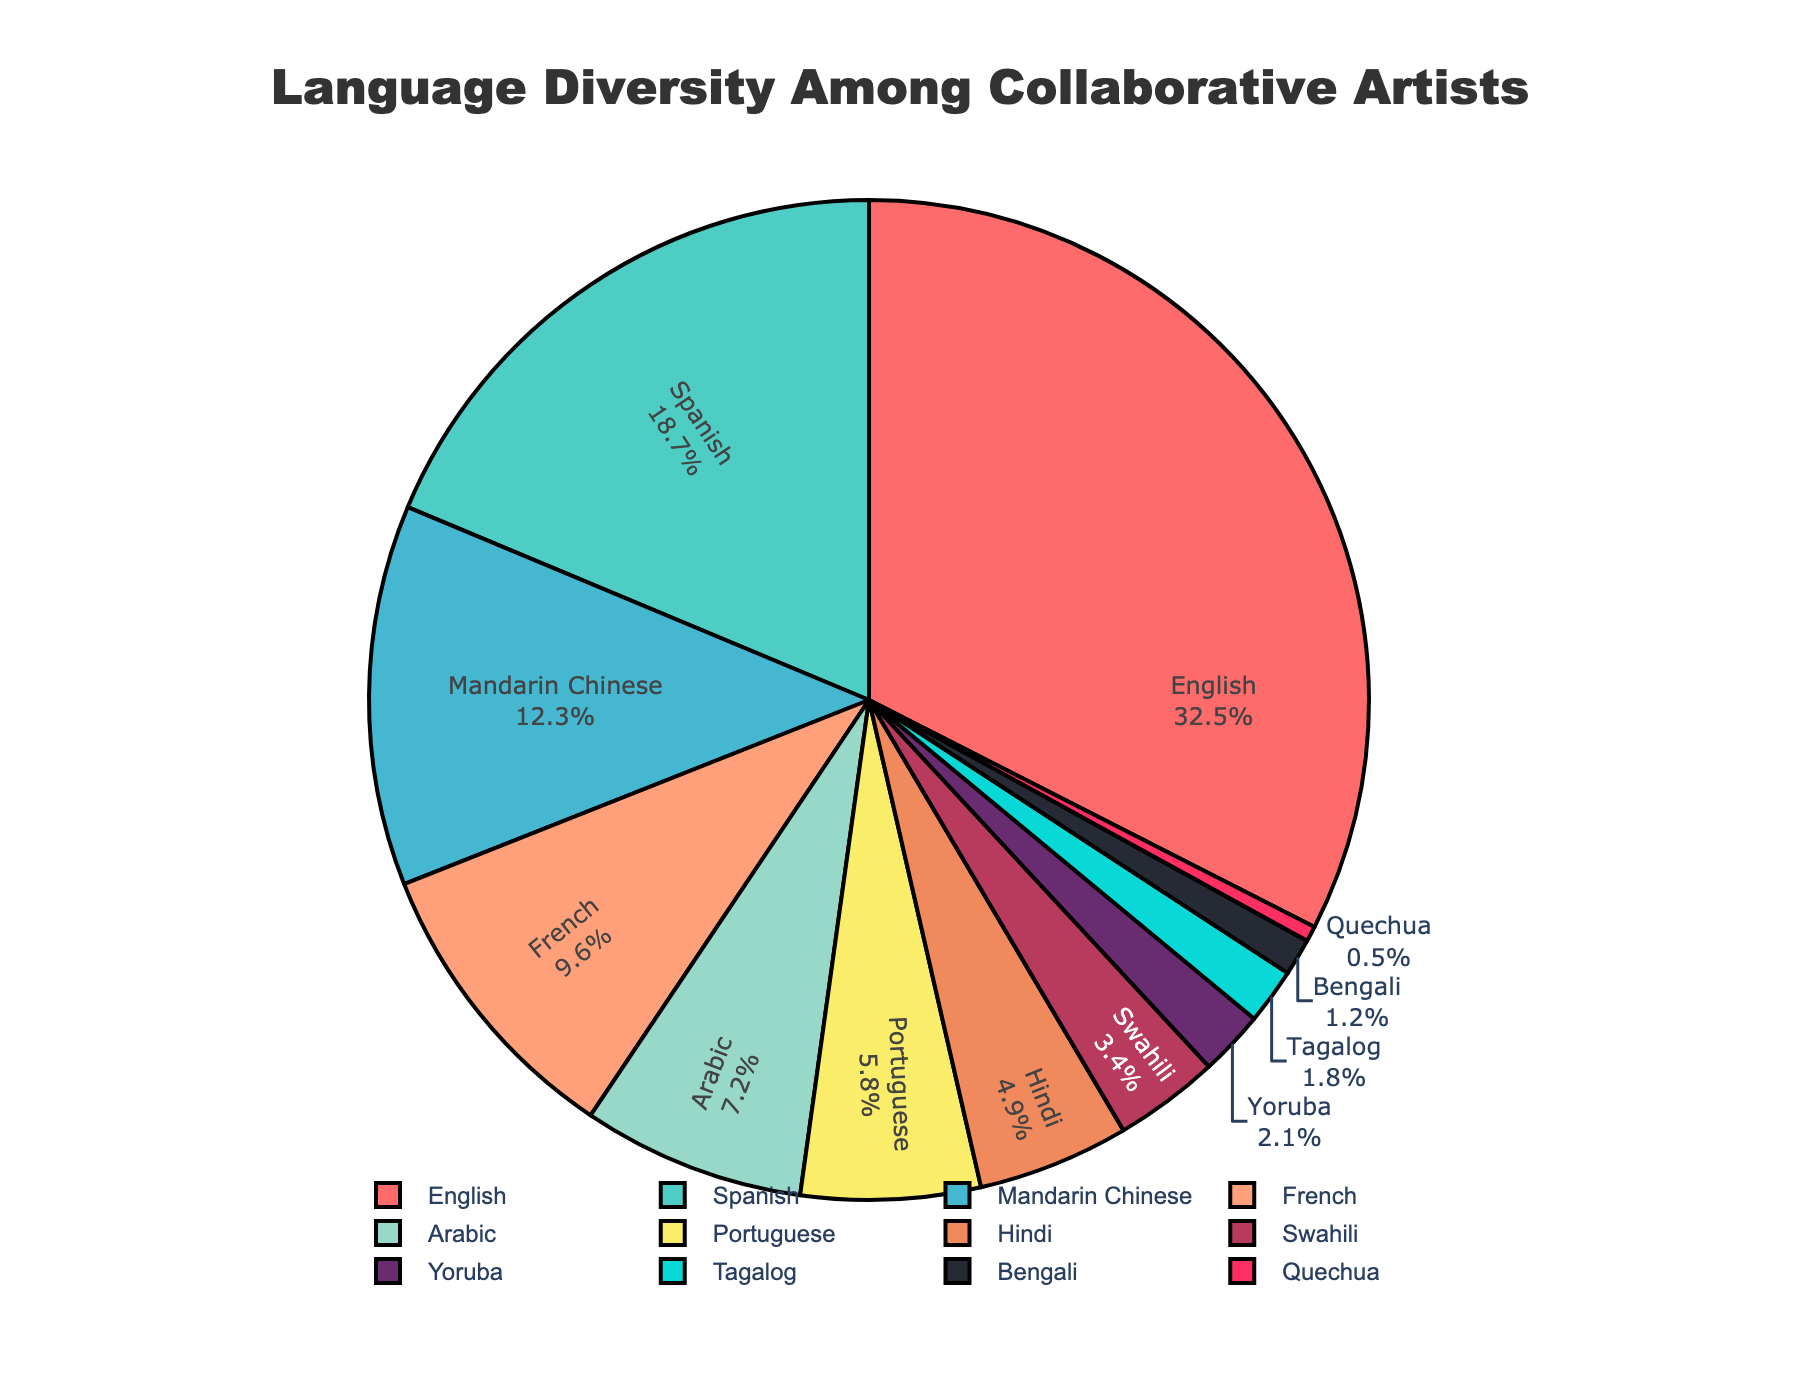What language has the largest percentage among collaborative artists? The figure shows a pie chart with different languages and their corresponding percentages. The largest segment of the pie chart is labeled "English" with 32.5%.
Answer: English Which language has the smallest percentage representation? By looking at the smallest segment of the pie chart, we see that "Quechua" is the least represented language with a percentage of 0.5%.
Answer: Quechua How many languages have a percentage higher than 10%? The pie chart shows 'English' (32.5%), 'Spanish' (18.7%), and 'Mandarin Chinese' (12.3%) as the segments with percentages over 10%. There are 3 such languages.
Answer: 3 What is the combined percentage of French and Arabic artists? French has 9.6% and Arabic has 7.2%. Adding these together: 9.6% + 7.2% = 16.8%.
Answer: 16.8% Compare the percentages of Hindi and Swahili. Which one is greater and by how much? The pie chart indicates 4.9% for Hindi and 3.4% for Swahili. Subtracting Swahili's percentage from Hindi's: 4.9% - 3.4% = 1.5%. Hindi is greater by 1.5%.
Answer: Hindi is greater by 1.5% What is the percentage difference between English and Portuguese artists? According to the chart, English has 32.5% and Portuguese has 5.8%. Subtracting Portuguese's percentage from English's: 32.5% - 5.8% = 26.7%.
Answer: 26.7% Which segment is colored red in the pie chart? The "English" segment is colored red in the pie chart based on the visual information provided.
Answer: English Are there more artists represented by Spanish or Mandarin Chinese? The pie chart shows Spanish with 18.7% and Mandarin Chinese with 12.3%. Spanish has a higher percentage than Mandarin Chinese.
Answer: Spanish What is the total percentage of artists represented by languages with more than 5% each? Languages above 5%: English (32.5%), Spanish (18.7%), Mandarin Chinese (12.3%), French (9.6%), Arabic (7.2%), Portuguese (5.8%). Summing these up: 32.5% + 18.7% + 12.3% + 9.6% + 7.2% + 5.8% = 86.1%.
Answer: 86.1% 